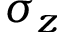<formula> <loc_0><loc_0><loc_500><loc_500>\sigma _ { z }</formula> 